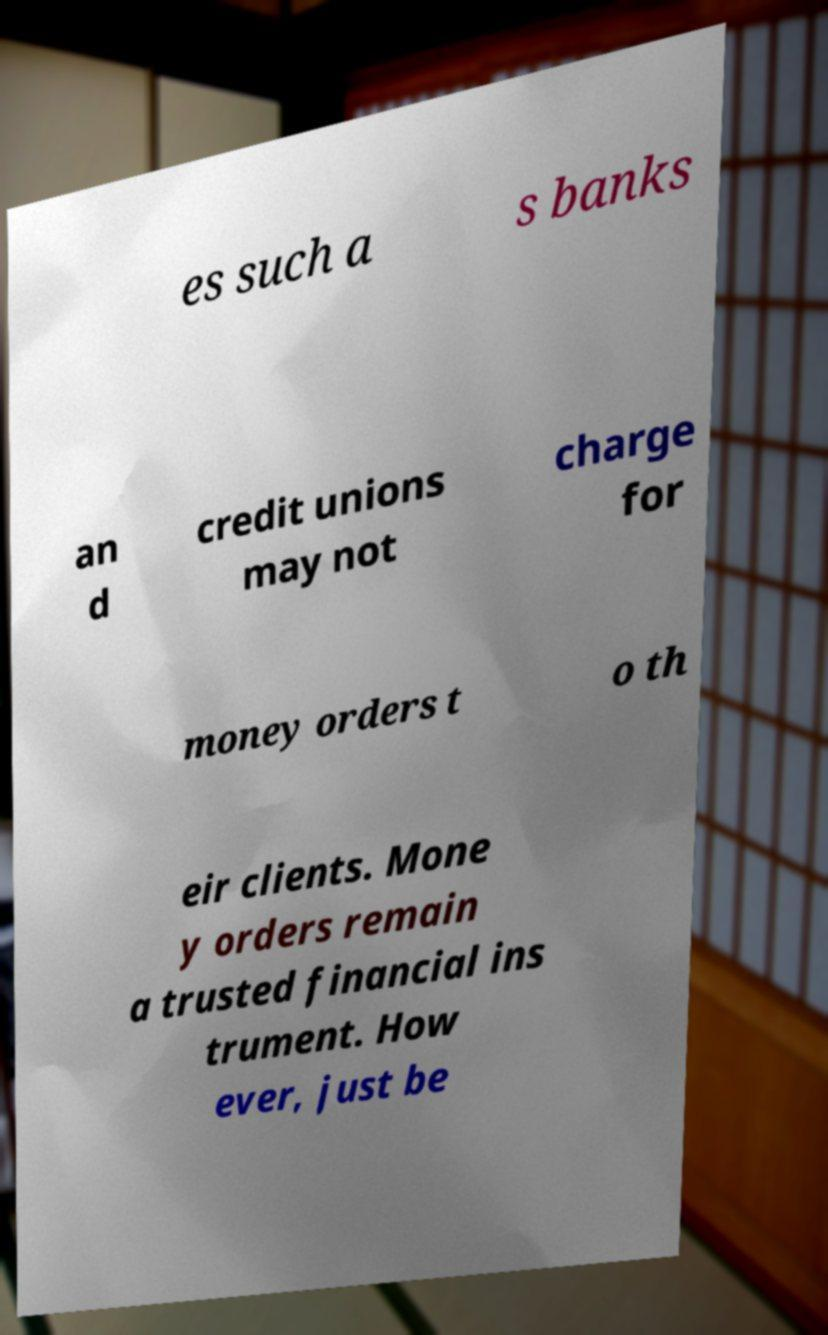Can you read and provide the text displayed in the image?This photo seems to have some interesting text. Can you extract and type it out for me? es such a s banks an d credit unions may not charge for money orders t o th eir clients. Mone y orders remain a trusted financial ins trument. How ever, just be 